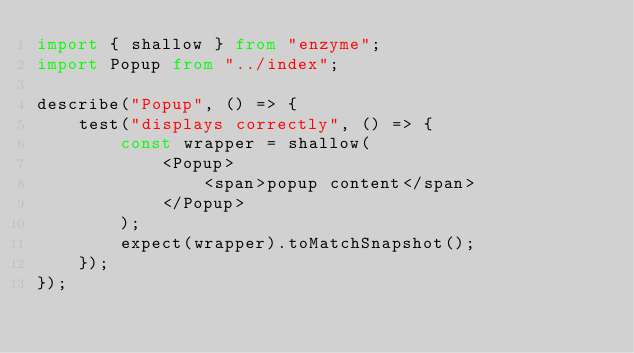<code> <loc_0><loc_0><loc_500><loc_500><_TypeScript_>import { shallow } from "enzyme";
import Popup from "../index";

describe("Popup", () => {
	test("displays correctly", () => {
		const wrapper = shallow(
			<Popup>
				<span>popup content</span>
			</Popup>
		);
		expect(wrapper).toMatchSnapshot();
	});
});
</code> 